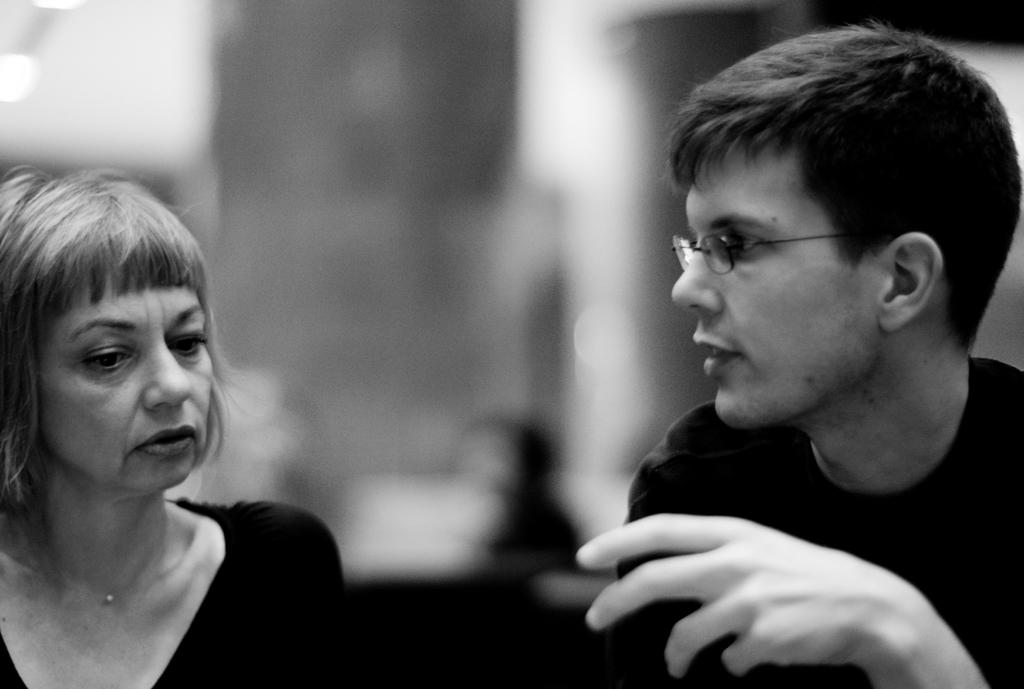How many people are visible in the image? There are two people in the image. Can you describe the background of the image? The background of the image is blurry. Is it possible to identify any other people in the background? It is uncertain if there are other people in the background due to the blurriness. How many dogs are visible in the image? There are no dogs present in the image. What event is about to start in the image? There is no event or activity depicted in the image. 